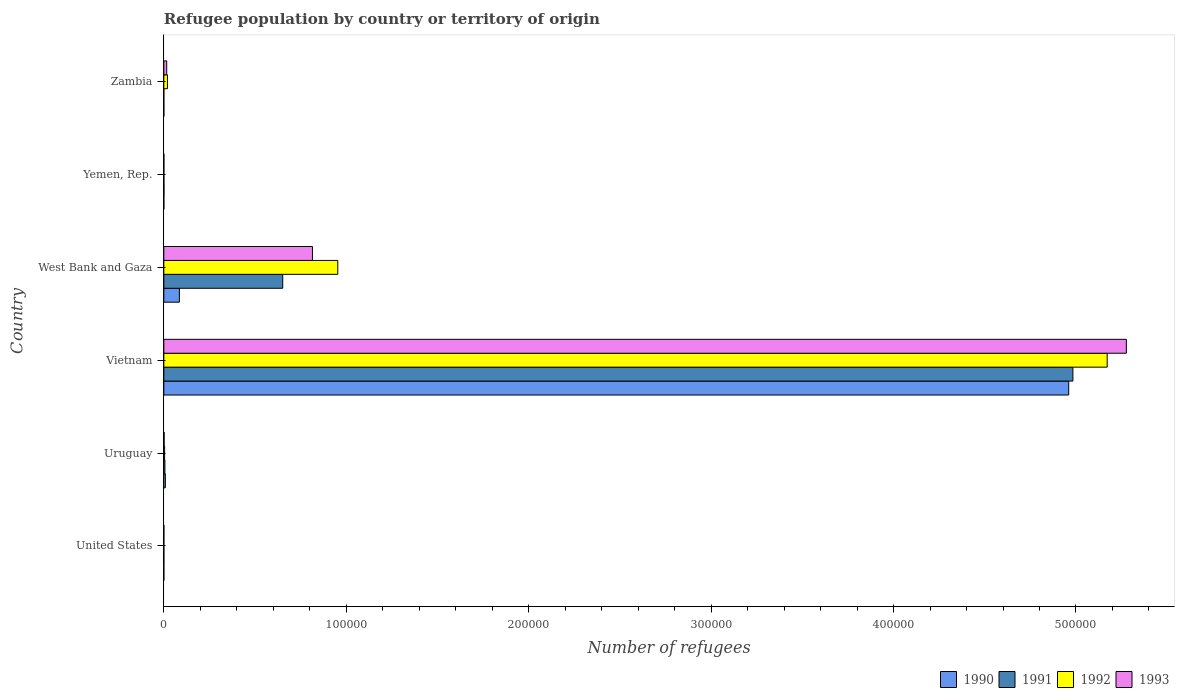What is the label of the 4th group of bars from the top?
Provide a short and direct response. Vietnam. In how many cases, is the number of bars for a given country not equal to the number of legend labels?
Your response must be concise. 0. What is the number of refugees in 1990 in West Bank and Gaza?
Your answer should be very brief. 8521. Across all countries, what is the maximum number of refugees in 1993?
Provide a succinct answer. 5.28e+05. In which country was the number of refugees in 1990 maximum?
Ensure brevity in your answer.  Vietnam. What is the total number of refugees in 1992 in the graph?
Your answer should be compact. 6.15e+05. What is the difference between the number of refugees in 1993 in Yemen, Rep. and that in Zambia?
Make the answer very short. -1535. What is the difference between the number of refugees in 1992 in Vietnam and the number of refugees in 1990 in Uruguay?
Make the answer very short. 5.16e+05. What is the average number of refugees in 1991 per country?
Your response must be concise. 9.40e+04. What is the difference between the number of refugees in 1992 and number of refugees in 1993 in Uruguay?
Offer a very short reply. 267. What is the ratio of the number of refugees in 1992 in Uruguay to that in Vietnam?
Give a very brief answer. 0. Is the number of refugees in 1993 in United States less than that in Yemen, Rep.?
Give a very brief answer. Yes. What is the difference between the highest and the second highest number of refugees in 1993?
Provide a succinct answer. 4.46e+05. What is the difference between the highest and the lowest number of refugees in 1993?
Your answer should be very brief. 5.28e+05. What does the 2nd bar from the top in Uruguay represents?
Keep it short and to the point. 1992. What does the 1st bar from the bottom in West Bank and Gaza represents?
Make the answer very short. 1990. Is it the case that in every country, the sum of the number of refugees in 1990 and number of refugees in 1993 is greater than the number of refugees in 1991?
Ensure brevity in your answer.  No. How many bars are there?
Your answer should be compact. 24. Are all the bars in the graph horizontal?
Provide a short and direct response. Yes. Does the graph contain any zero values?
Provide a short and direct response. No. Does the graph contain grids?
Your answer should be compact. No. What is the title of the graph?
Your answer should be compact. Refugee population by country or territory of origin. Does "2015" appear as one of the legend labels in the graph?
Your answer should be very brief. No. What is the label or title of the X-axis?
Provide a short and direct response. Number of refugees. What is the Number of refugees in 1992 in United States?
Your answer should be very brief. 10. What is the Number of refugees of 1993 in United States?
Offer a terse response. 12. What is the Number of refugees in 1990 in Uruguay?
Your answer should be very brief. 842. What is the Number of refugees of 1991 in Uruguay?
Your answer should be compact. 601. What is the Number of refugees in 1992 in Uruguay?
Offer a terse response. 429. What is the Number of refugees of 1993 in Uruguay?
Your answer should be very brief. 162. What is the Number of refugees of 1990 in Vietnam?
Your response must be concise. 4.96e+05. What is the Number of refugees in 1991 in Vietnam?
Keep it short and to the point. 4.98e+05. What is the Number of refugees of 1992 in Vietnam?
Give a very brief answer. 5.17e+05. What is the Number of refugees in 1993 in Vietnam?
Ensure brevity in your answer.  5.28e+05. What is the Number of refugees of 1990 in West Bank and Gaza?
Your response must be concise. 8521. What is the Number of refugees in 1991 in West Bank and Gaza?
Provide a succinct answer. 6.52e+04. What is the Number of refugees in 1992 in West Bank and Gaza?
Your answer should be very brief. 9.53e+04. What is the Number of refugees of 1993 in West Bank and Gaza?
Give a very brief answer. 8.15e+04. What is the Number of refugees of 1993 in Yemen, Rep.?
Ensure brevity in your answer.  39. What is the Number of refugees in 1990 in Zambia?
Ensure brevity in your answer.  1. What is the Number of refugees in 1992 in Zambia?
Make the answer very short. 1990. What is the Number of refugees of 1993 in Zambia?
Offer a terse response. 1574. Across all countries, what is the maximum Number of refugees in 1990?
Your answer should be very brief. 4.96e+05. Across all countries, what is the maximum Number of refugees in 1991?
Ensure brevity in your answer.  4.98e+05. Across all countries, what is the maximum Number of refugees of 1992?
Provide a succinct answer. 5.17e+05. Across all countries, what is the maximum Number of refugees in 1993?
Offer a very short reply. 5.28e+05. Across all countries, what is the minimum Number of refugees of 1991?
Your response must be concise. 1. Across all countries, what is the minimum Number of refugees of 1993?
Ensure brevity in your answer.  12. What is the total Number of refugees of 1990 in the graph?
Offer a very short reply. 5.05e+05. What is the total Number of refugees in 1991 in the graph?
Keep it short and to the point. 5.64e+05. What is the total Number of refugees of 1992 in the graph?
Offer a terse response. 6.15e+05. What is the total Number of refugees in 1993 in the graph?
Make the answer very short. 6.11e+05. What is the difference between the Number of refugees of 1990 in United States and that in Uruguay?
Give a very brief answer. -841. What is the difference between the Number of refugees in 1991 in United States and that in Uruguay?
Offer a terse response. -593. What is the difference between the Number of refugees in 1992 in United States and that in Uruguay?
Your answer should be very brief. -419. What is the difference between the Number of refugees in 1993 in United States and that in Uruguay?
Ensure brevity in your answer.  -150. What is the difference between the Number of refugees in 1990 in United States and that in Vietnam?
Offer a terse response. -4.96e+05. What is the difference between the Number of refugees of 1991 in United States and that in Vietnam?
Your answer should be compact. -4.98e+05. What is the difference between the Number of refugees of 1992 in United States and that in Vietnam?
Give a very brief answer. -5.17e+05. What is the difference between the Number of refugees in 1993 in United States and that in Vietnam?
Your response must be concise. -5.28e+05. What is the difference between the Number of refugees of 1990 in United States and that in West Bank and Gaza?
Provide a succinct answer. -8520. What is the difference between the Number of refugees of 1991 in United States and that in West Bank and Gaza?
Offer a terse response. -6.52e+04. What is the difference between the Number of refugees in 1992 in United States and that in West Bank and Gaza?
Ensure brevity in your answer.  -9.53e+04. What is the difference between the Number of refugees in 1993 in United States and that in West Bank and Gaza?
Your response must be concise. -8.15e+04. What is the difference between the Number of refugees in 1990 in United States and that in Yemen, Rep.?
Provide a short and direct response. -7. What is the difference between the Number of refugees of 1991 in United States and that in Yemen, Rep.?
Provide a succinct answer. -65. What is the difference between the Number of refugees in 1992 in United States and that in Yemen, Rep.?
Provide a short and direct response. -21. What is the difference between the Number of refugees of 1993 in United States and that in Yemen, Rep.?
Your answer should be very brief. -27. What is the difference between the Number of refugees of 1990 in United States and that in Zambia?
Your answer should be compact. 0. What is the difference between the Number of refugees of 1991 in United States and that in Zambia?
Offer a terse response. 7. What is the difference between the Number of refugees of 1992 in United States and that in Zambia?
Provide a succinct answer. -1980. What is the difference between the Number of refugees of 1993 in United States and that in Zambia?
Keep it short and to the point. -1562. What is the difference between the Number of refugees of 1990 in Uruguay and that in Vietnam?
Provide a short and direct response. -4.95e+05. What is the difference between the Number of refugees of 1991 in Uruguay and that in Vietnam?
Keep it short and to the point. -4.98e+05. What is the difference between the Number of refugees of 1992 in Uruguay and that in Vietnam?
Offer a very short reply. -5.17e+05. What is the difference between the Number of refugees in 1993 in Uruguay and that in Vietnam?
Your answer should be very brief. -5.27e+05. What is the difference between the Number of refugees of 1990 in Uruguay and that in West Bank and Gaza?
Keep it short and to the point. -7679. What is the difference between the Number of refugees of 1991 in Uruguay and that in West Bank and Gaza?
Provide a succinct answer. -6.46e+04. What is the difference between the Number of refugees of 1992 in Uruguay and that in West Bank and Gaza?
Make the answer very short. -9.49e+04. What is the difference between the Number of refugees of 1993 in Uruguay and that in West Bank and Gaza?
Ensure brevity in your answer.  -8.13e+04. What is the difference between the Number of refugees of 1990 in Uruguay and that in Yemen, Rep.?
Provide a short and direct response. 834. What is the difference between the Number of refugees in 1991 in Uruguay and that in Yemen, Rep.?
Make the answer very short. 528. What is the difference between the Number of refugees in 1992 in Uruguay and that in Yemen, Rep.?
Ensure brevity in your answer.  398. What is the difference between the Number of refugees of 1993 in Uruguay and that in Yemen, Rep.?
Keep it short and to the point. 123. What is the difference between the Number of refugees in 1990 in Uruguay and that in Zambia?
Your answer should be very brief. 841. What is the difference between the Number of refugees in 1991 in Uruguay and that in Zambia?
Your answer should be compact. 600. What is the difference between the Number of refugees of 1992 in Uruguay and that in Zambia?
Your answer should be compact. -1561. What is the difference between the Number of refugees of 1993 in Uruguay and that in Zambia?
Provide a short and direct response. -1412. What is the difference between the Number of refugees of 1990 in Vietnam and that in West Bank and Gaza?
Ensure brevity in your answer.  4.88e+05. What is the difference between the Number of refugees of 1991 in Vietnam and that in West Bank and Gaza?
Offer a very short reply. 4.33e+05. What is the difference between the Number of refugees in 1992 in Vietnam and that in West Bank and Gaza?
Provide a succinct answer. 4.22e+05. What is the difference between the Number of refugees in 1993 in Vietnam and that in West Bank and Gaza?
Give a very brief answer. 4.46e+05. What is the difference between the Number of refugees of 1990 in Vietnam and that in Yemen, Rep.?
Your answer should be compact. 4.96e+05. What is the difference between the Number of refugees of 1991 in Vietnam and that in Yemen, Rep.?
Provide a succinct answer. 4.98e+05. What is the difference between the Number of refugees in 1992 in Vietnam and that in Yemen, Rep.?
Make the answer very short. 5.17e+05. What is the difference between the Number of refugees in 1993 in Vietnam and that in Yemen, Rep.?
Keep it short and to the point. 5.28e+05. What is the difference between the Number of refugees in 1990 in Vietnam and that in Zambia?
Give a very brief answer. 4.96e+05. What is the difference between the Number of refugees in 1991 in Vietnam and that in Zambia?
Offer a terse response. 4.98e+05. What is the difference between the Number of refugees of 1992 in Vietnam and that in Zambia?
Ensure brevity in your answer.  5.15e+05. What is the difference between the Number of refugees in 1993 in Vietnam and that in Zambia?
Your response must be concise. 5.26e+05. What is the difference between the Number of refugees of 1990 in West Bank and Gaza and that in Yemen, Rep.?
Ensure brevity in your answer.  8513. What is the difference between the Number of refugees of 1991 in West Bank and Gaza and that in Yemen, Rep.?
Offer a terse response. 6.51e+04. What is the difference between the Number of refugees in 1992 in West Bank and Gaza and that in Yemen, Rep.?
Offer a terse response. 9.53e+04. What is the difference between the Number of refugees in 1993 in West Bank and Gaza and that in Yemen, Rep.?
Offer a very short reply. 8.14e+04. What is the difference between the Number of refugees in 1990 in West Bank and Gaza and that in Zambia?
Keep it short and to the point. 8520. What is the difference between the Number of refugees of 1991 in West Bank and Gaza and that in Zambia?
Your response must be concise. 6.52e+04. What is the difference between the Number of refugees in 1992 in West Bank and Gaza and that in Zambia?
Keep it short and to the point. 9.34e+04. What is the difference between the Number of refugees in 1993 in West Bank and Gaza and that in Zambia?
Your response must be concise. 7.99e+04. What is the difference between the Number of refugees in 1990 in Yemen, Rep. and that in Zambia?
Your answer should be compact. 7. What is the difference between the Number of refugees of 1991 in Yemen, Rep. and that in Zambia?
Provide a short and direct response. 72. What is the difference between the Number of refugees in 1992 in Yemen, Rep. and that in Zambia?
Offer a terse response. -1959. What is the difference between the Number of refugees in 1993 in Yemen, Rep. and that in Zambia?
Provide a succinct answer. -1535. What is the difference between the Number of refugees of 1990 in United States and the Number of refugees of 1991 in Uruguay?
Keep it short and to the point. -600. What is the difference between the Number of refugees of 1990 in United States and the Number of refugees of 1992 in Uruguay?
Make the answer very short. -428. What is the difference between the Number of refugees in 1990 in United States and the Number of refugees in 1993 in Uruguay?
Offer a very short reply. -161. What is the difference between the Number of refugees of 1991 in United States and the Number of refugees of 1992 in Uruguay?
Provide a succinct answer. -421. What is the difference between the Number of refugees of 1991 in United States and the Number of refugees of 1993 in Uruguay?
Make the answer very short. -154. What is the difference between the Number of refugees of 1992 in United States and the Number of refugees of 1993 in Uruguay?
Offer a very short reply. -152. What is the difference between the Number of refugees of 1990 in United States and the Number of refugees of 1991 in Vietnam?
Make the answer very short. -4.98e+05. What is the difference between the Number of refugees of 1990 in United States and the Number of refugees of 1992 in Vietnam?
Keep it short and to the point. -5.17e+05. What is the difference between the Number of refugees in 1990 in United States and the Number of refugees in 1993 in Vietnam?
Provide a succinct answer. -5.28e+05. What is the difference between the Number of refugees of 1991 in United States and the Number of refugees of 1992 in Vietnam?
Offer a very short reply. -5.17e+05. What is the difference between the Number of refugees of 1991 in United States and the Number of refugees of 1993 in Vietnam?
Your answer should be very brief. -5.28e+05. What is the difference between the Number of refugees in 1992 in United States and the Number of refugees in 1993 in Vietnam?
Ensure brevity in your answer.  -5.28e+05. What is the difference between the Number of refugees of 1990 in United States and the Number of refugees of 1991 in West Bank and Gaza?
Provide a succinct answer. -6.52e+04. What is the difference between the Number of refugees of 1990 in United States and the Number of refugees of 1992 in West Bank and Gaza?
Give a very brief answer. -9.53e+04. What is the difference between the Number of refugees of 1990 in United States and the Number of refugees of 1993 in West Bank and Gaza?
Offer a very short reply. -8.15e+04. What is the difference between the Number of refugees of 1991 in United States and the Number of refugees of 1992 in West Bank and Gaza?
Keep it short and to the point. -9.53e+04. What is the difference between the Number of refugees in 1991 in United States and the Number of refugees in 1993 in West Bank and Gaza?
Provide a succinct answer. -8.15e+04. What is the difference between the Number of refugees of 1992 in United States and the Number of refugees of 1993 in West Bank and Gaza?
Ensure brevity in your answer.  -8.15e+04. What is the difference between the Number of refugees of 1990 in United States and the Number of refugees of 1991 in Yemen, Rep.?
Provide a short and direct response. -72. What is the difference between the Number of refugees of 1990 in United States and the Number of refugees of 1992 in Yemen, Rep.?
Provide a succinct answer. -30. What is the difference between the Number of refugees of 1990 in United States and the Number of refugees of 1993 in Yemen, Rep.?
Your answer should be compact. -38. What is the difference between the Number of refugees in 1991 in United States and the Number of refugees in 1992 in Yemen, Rep.?
Ensure brevity in your answer.  -23. What is the difference between the Number of refugees in 1991 in United States and the Number of refugees in 1993 in Yemen, Rep.?
Your response must be concise. -31. What is the difference between the Number of refugees in 1992 in United States and the Number of refugees in 1993 in Yemen, Rep.?
Your answer should be compact. -29. What is the difference between the Number of refugees in 1990 in United States and the Number of refugees in 1991 in Zambia?
Give a very brief answer. 0. What is the difference between the Number of refugees in 1990 in United States and the Number of refugees in 1992 in Zambia?
Offer a very short reply. -1989. What is the difference between the Number of refugees of 1990 in United States and the Number of refugees of 1993 in Zambia?
Provide a succinct answer. -1573. What is the difference between the Number of refugees in 1991 in United States and the Number of refugees in 1992 in Zambia?
Your response must be concise. -1982. What is the difference between the Number of refugees of 1991 in United States and the Number of refugees of 1993 in Zambia?
Your answer should be very brief. -1566. What is the difference between the Number of refugees in 1992 in United States and the Number of refugees in 1993 in Zambia?
Keep it short and to the point. -1564. What is the difference between the Number of refugees in 1990 in Uruguay and the Number of refugees in 1991 in Vietnam?
Ensure brevity in your answer.  -4.97e+05. What is the difference between the Number of refugees in 1990 in Uruguay and the Number of refugees in 1992 in Vietnam?
Provide a short and direct response. -5.16e+05. What is the difference between the Number of refugees of 1990 in Uruguay and the Number of refugees of 1993 in Vietnam?
Offer a terse response. -5.27e+05. What is the difference between the Number of refugees of 1991 in Uruguay and the Number of refugees of 1992 in Vietnam?
Give a very brief answer. -5.17e+05. What is the difference between the Number of refugees in 1991 in Uruguay and the Number of refugees in 1993 in Vietnam?
Your answer should be very brief. -5.27e+05. What is the difference between the Number of refugees of 1992 in Uruguay and the Number of refugees of 1993 in Vietnam?
Offer a very short reply. -5.27e+05. What is the difference between the Number of refugees of 1990 in Uruguay and the Number of refugees of 1991 in West Bank and Gaza?
Your answer should be very brief. -6.43e+04. What is the difference between the Number of refugees in 1990 in Uruguay and the Number of refugees in 1992 in West Bank and Gaza?
Keep it short and to the point. -9.45e+04. What is the difference between the Number of refugees in 1990 in Uruguay and the Number of refugees in 1993 in West Bank and Gaza?
Your answer should be very brief. -8.06e+04. What is the difference between the Number of refugees of 1991 in Uruguay and the Number of refugees of 1992 in West Bank and Gaza?
Keep it short and to the point. -9.47e+04. What is the difference between the Number of refugees in 1991 in Uruguay and the Number of refugees in 1993 in West Bank and Gaza?
Keep it short and to the point. -8.09e+04. What is the difference between the Number of refugees of 1992 in Uruguay and the Number of refugees of 1993 in West Bank and Gaza?
Offer a very short reply. -8.10e+04. What is the difference between the Number of refugees of 1990 in Uruguay and the Number of refugees of 1991 in Yemen, Rep.?
Ensure brevity in your answer.  769. What is the difference between the Number of refugees in 1990 in Uruguay and the Number of refugees in 1992 in Yemen, Rep.?
Offer a very short reply. 811. What is the difference between the Number of refugees of 1990 in Uruguay and the Number of refugees of 1993 in Yemen, Rep.?
Make the answer very short. 803. What is the difference between the Number of refugees in 1991 in Uruguay and the Number of refugees in 1992 in Yemen, Rep.?
Your response must be concise. 570. What is the difference between the Number of refugees of 1991 in Uruguay and the Number of refugees of 1993 in Yemen, Rep.?
Offer a terse response. 562. What is the difference between the Number of refugees of 1992 in Uruguay and the Number of refugees of 1993 in Yemen, Rep.?
Make the answer very short. 390. What is the difference between the Number of refugees of 1990 in Uruguay and the Number of refugees of 1991 in Zambia?
Provide a short and direct response. 841. What is the difference between the Number of refugees in 1990 in Uruguay and the Number of refugees in 1992 in Zambia?
Give a very brief answer. -1148. What is the difference between the Number of refugees of 1990 in Uruguay and the Number of refugees of 1993 in Zambia?
Provide a short and direct response. -732. What is the difference between the Number of refugees in 1991 in Uruguay and the Number of refugees in 1992 in Zambia?
Offer a very short reply. -1389. What is the difference between the Number of refugees of 1991 in Uruguay and the Number of refugees of 1993 in Zambia?
Offer a very short reply. -973. What is the difference between the Number of refugees in 1992 in Uruguay and the Number of refugees in 1993 in Zambia?
Your answer should be compact. -1145. What is the difference between the Number of refugees of 1990 in Vietnam and the Number of refugees of 1991 in West Bank and Gaza?
Your answer should be compact. 4.31e+05. What is the difference between the Number of refugees of 1990 in Vietnam and the Number of refugees of 1992 in West Bank and Gaza?
Keep it short and to the point. 4.01e+05. What is the difference between the Number of refugees in 1990 in Vietnam and the Number of refugees in 1993 in West Bank and Gaza?
Your answer should be compact. 4.15e+05. What is the difference between the Number of refugees in 1991 in Vietnam and the Number of refugees in 1992 in West Bank and Gaza?
Your response must be concise. 4.03e+05. What is the difference between the Number of refugees of 1991 in Vietnam and the Number of refugees of 1993 in West Bank and Gaza?
Give a very brief answer. 4.17e+05. What is the difference between the Number of refugees in 1992 in Vietnam and the Number of refugees in 1993 in West Bank and Gaza?
Keep it short and to the point. 4.36e+05. What is the difference between the Number of refugees of 1990 in Vietnam and the Number of refugees of 1991 in Yemen, Rep.?
Your answer should be very brief. 4.96e+05. What is the difference between the Number of refugees in 1990 in Vietnam and the Number of refugees in 1992 in Yemen, Rep.?
Offer a terse response. 4.96e+05. What is the difference between the Number of refugees of 1990 in Vietnam and the Number of refugees of 1993 in Yemen, Rep.?
Keep it short and to the point. 4.96e+05. What is the difference between the Number of refugees in 1991 in Vietnam and the Number of refugees in 1992 in Yemen, Rep.?
Give a very brief answer. 4.98e+05. What is the difference between the Number of refugees of 1991 in Vietnam and the Number of refugees of 1993 in Yemen, Rep.?
Make the answer very short. 4.98e+05. What is the difference between the Number of refugees in 1992 in Vietnam and the Number of refugees in 1993 in Yemen, Rep.?
Keep it short and to the point. 5.17e+05. What is the difference between the Number of refugees of 1990 in Vietnam and the Number of refugees of 1991 in Zambia?
Keep it short and to the point. 4.96e+05. What is the difference between the Number of refugees in 1990 in Vietnam and the Number of refugees in 1992 in Zambia?
Provide a succinct answer. 4.94e+05. What is the difference between the Number of refugees in 1990 in Vietnam and the Number of refugees in 1993 in Zambia?
Make the answer very short. 4.94e+05. What is the difference between the Number of refugees of 1991 in Vietnam and the Number of refugees of 1992 in Zambia?
Make the answer very short. 4.96e+05. What is the difference between the Number of refugees in 1991 in Vietnam and the Number of refugees in 1993 in Zambia?
Your answer should be very brief. 4.97e+05. What is the difference between the Number of refugees of 1992 in Vietnam and the Number of refugees of 1993 in Zambia?
Your answer should be compact. 5.16e+05. What is the difference between the Number of refugees of 1990 in West Bank and Gaza and the Number of refugees of 1991 in Yemen, Rep.?
Give a very brief answer. 8448. What is the difference between the Number of refugees in 1990 in West Bank and Gaza and the Number of refugees in 1992 in Yemen, Rep.?
Provide a short and direct response. 8490. What is the difference between the Number of refugees in 1990 in West Bank and Gaza and the Number of refugees in 1993 in Yemen, Rep.?
Offer a terse response. 8482. What is the difference between the Number of refugees in 1991 in West Bank and Gaza and the Number of refugees in 1992 in Yemen, Rep.?
Your answer should be very brief. 6.51e+04. What is the difference between the Number of refugees in 1991 in West Bank and Gaza and the Number of refugees in 1993 in Yemen, Rep.?
Keep it short and to the point. 6.51e+04. What is the difference between the Number of refugees of 1992 in West Bank and Gaza and the Number of refugees of 1993 in Yemen, Rep.?
Offer a very short reply. 9.53e+04. What is the difference between the Number of refugees of 1990 in West Bank and Gaza and the Number of refugees of 1991 in Zambia?
Offer a very short reply. 8520. What is the difference between the Number of refugees in 1990 in West Bank and Gaza and the Number of refugees in 1992 in Zambia?
Ensure brevity in your answer.  6531. What is the difference between the Number of refugees of 1990 in West Bank and Gaza and the Number of refugees of 1993 in Zambia?
Provide a succinct answer. 6947. What is the difference between the Number of refugees of 1991 in West Bank and Gaza and the Number of refugees of 1992 in Zambia?
Provide a short and direct response. 6.32e+04. What is the difference between the Number of refugees in 1991 in West Bank and Gaza and the Number of refugees in 1993 in Zambia?
Provide a succinct answer. 6.36e+04. What is the difference between the Number of refugees of 1992 in West Bank and Gaza and the Number of refugees of 1993 in Zambia?
Make the answer very short. 9.38e+04. What is the difference between the Number of refugees of 1990 in Yemen, Rep. and the Number of refugees of 1991 in Zambia?
Your answer should be compact. 7. What is the difference between the Number of refugees of 1990 in Yemen, Rep. and the Number of refugees of 1992 in Zambia?
Your answer should be very brief. -1982. What is the difference between the Number of refugees in 1990 in Yemen, Rep. and the Number of refugees in 1993 in Zambia?
Your answer should be compact. -1566. What is the difference between the Number of refugees in 1991 in Yemen, Rep. and the Number of refugees in 1992 in Zambia?
Give a very brief answer. -1917. What is the difference between the Number of refugees in 1991 in Yemen, Rep. and the Number of refugees in 1993 in Zambia?
Provide a succinct answer. -1501. What is the difference between the Number of refugees of 1992 in Yemen, Rep. and the Number of refugees of 1993 in Zambia?
Make the answer very short. -1543. What is the average Number of refugees in 1990 per country?
Provide a short and direct response. 8.42e+04. What is the average Number of refugees in 1991 per country?
Offer a very short reply. 9.40e+04. What is the average Number of refugees in 1992 per country?
Ensure brevity in your answer.  1.02e+05. What is the average Number of refugees of 1993 per country?
Provide a succinct answer. 1.02e+05. What is the difference between the Number of refugees in 1991 and Number of refugees in 1993 in United States?
Provide a short and direct response. -4. What is the difference between the Number of refugees of 1992 and Number of refugees of 1993 in United States?
Provide a short and direct response. -2. What is the difference between the Number of refugees in 1990 and Number of refugees in 1991 in Uruguay?
Your answer should be very brief. 241. What is the difference between the Number of refugees in 1990 and Number of refugees in 1992 in Uruguay?
Make the answer very short. 413. What is the difference between the Number of refugees in 1990 and Number of refugees in 1993 in Uruguay?
Provide a succinct answer. 680. What is the difference between the Number of refugees in 1991 and Number of refugees in 1992 in Uruguay?
Your answer should be very brief. 172. What is the difference between the Number of refugees in 1991 and Number of refugees in 1993 in Uruguay?
Your response must be concise. 439. What is the difference between the Number of refugees of 1992 and Number of refugees of 1993 in Uruguay?
Ensure brevity in your answer.  267. What is the difference between the Number of refugees of 1990 and Number of refugees of 1991 in Vietnam?
Ensure brevity in your answer.  -2294. What is the difference between the Number of refugees of 1990 and Number of refugees of 1992 in Vietnam?
Your answer should be compact. -2.11e+04. What is the difference between the Number of refugees in 1990 and Number of refugees in 1993 in Vietnam?
Offer a very short reply. -3.16e+04. What is the difference between the Number of refugees in 1991 and Number of refugees in 1992 in Vietnam?
Your answer should be compact. -1.88e+04. What is the difference between the Number of refugees of 1991 and Number of refugees of 1993 in Vietnam?
Your response must be concise. -2.93e+04. What is the difference between the Number of refugees in 1992 and Number of refugees in 1993 in Vietnam?
Your response must be concise. -1.05e+04. What is the difference between the Number of refugees of 1990 and Number of refugees of 1991 in West Bank and Gaza?
Provide a short and direct response. -5.67e+04. What is the difference between the Number of refugees in 1990 and Number of refugees in 1992 in West Bank and Gaza?
Ensure brevity in your answer.  -8.68e+04. What is the difference between the Number of refugees of 1990 and Number of refugees of 1993 in West Bank and Gaza?
Your answer should be compact. -7.30e+04. What is the difference between the Number of refugees of 1991 and Number of refugees of 1992 in West Bank and Gaza?
Provide a short and direct response. -3.02e+04. What is the difference between the Number of refugees in 1991 and Number of refugees in 1993 in West Bank and Gaza?
Keep it short and to the point. -1.63e+04. What is the difference between the Number of refugees in 1992 and Number of refugees in 1993 in West Bank and Gaza?
Your answer should be compact. 1.39e+04. What is the difference between the Number of refugees in 1990 and Number of refugees in 1991 in Yemen, Rep.?
Your answer should be very brief. -65. What is the difference between the Number of refugees in 1990 and Number of refugees in 1992 in Yemen, Rep.?
Offer a terse response. -23. What is the difference between the Number of refugees of 1990 and Number of refugees of 1993 in Yemen, Rep.?
Provide a short and direct response. -31. What is the difference between the Number of refugees of 1992 and Number of refugees of 1993 in Yemen, Rep.?
Give a very brief answer. -8. What is the difference between the Number of refugees in 1990 and Number of refugees in 1992 in Zambia?
Offer a terse response. -1989. What is the difference between the Number of refugees in 1990 and Number of refugees in 1993 in Zambia?
Provide a succinct answer. -1573. What is the difference between the Number of refugees of 1991 and Number of refugees of 1992 in Zambia?
Make the answer very short. -1989. What is the difference between the Number of refugees in 1991 and Number of refugees in 1993 in Zambia?
Make the answer very short. -1573. What is the difference between the Number of refugees in 1992 and Number of refugees in 1993 in Zambia?
Your answer should be compact. 416. What is the ratio of the Number of refugees in 1990 in United States to that in Uruguay?
Ensure brevity in your answer.  0. What is the ratio of the Number of refugees in 1991 in United States to that in Uruguay?
Offer a very short reply. 0.01. What is the ratio of the Number of refugees of 1992 in United States to that in Uruguay?
Make the answer very short. 0.02. What is the ratio of the Number of refugees in 1993 in United States to that in Uruguay?
Give a very brief answer. 0.07. What is the ratio of the Number of refugees of 1990 in United States to that in Vietnam?
Your response must be concise. 0. What is the ratio of the Number of refugees of 1991 in United States to that in Vietnam?
Your response must be concise. 0. What is the ratio of the Number of refugees of 1992 in United States to that in Vietnam?
Ensure brevity in your answer.  0. What is the ratio of the Number of refugees in 1993 in United States to that in Vietnam?
Make the answer very short. 0. What is the ratio of the Number of refugees in 1991 in United States to that in West Bank and Gaza?
Provide a succinct answer. 0. What is the ratio of the Number of refugees of 1992 in United States to that in West Bank and Gaza?
Make the answer very short. 0. What is the ratio of the Number of refugees in 1993 in United States to that in West Bank and Gaza?
Offer a terse response. 0. What is the ratio of the Number of refugees of 1991 in United States to that in Yemen, Rep.?
Ensure brevity in your answer.  0.11. What is the ratio of the Number of refugees in 1992 in United States to that in Yemen, Rep.?
Your answer should be compact. 0.32. What is the ratio of the Number of refugees of 1993 in United States to that in Yemen, Rep.?
Your answer should be very brief. 0.31. What is the ratio of the Number of refugees in 1990 in United States to that in Zambia?
Your answer should be very brief. 1. What is the ratio of the Number of refugees in 1991 in United States to that in Zambia?
Your answer should be compact. 8. What is the ratio of the Number of refugees in 1992 in United States to that in Zambia?
Keep it short and to the point. 0.01. What is the ratio of the Number of refugees in 1993 in United States to that in Zambia?
Offer a very short reply. 0.01. What is the ratio of the Number of refugees in 1990 in Uruguay to that in Vietnam?
Ensure brevity in your answer.  0. What is the ratio of the Number of refugees of 1991 in Uruguay to that in Vietnam?
Offer a terse response. 0. What is the ratio of the Number of refugees of 1992 in Uruguay to that in Vietnam?
Your answer should be compact. 0. What is the ratio of the Number of refugees of 1993 in Uruguay to that in Vietnam?
Give a very brief answer. 0. What is the ratio of the Number of refugees in 1990 in Uruguay to that in West Bank and Gaza?
Your answer should be compact. 0.1. What is the ratio of the Number of refugees in 1991 in Uruguay to that in West Bank and Gaza?
Your answer should be very brief. 0.01. What is the ratio of the Number of refugees in 1992 in Uruguay to that in West Bank and Gaza?
Ensure brevity in your answer.  0. What is the ratio of the Number of refugees in 1993 in Uruguay to that in West Bank and Gaza?
Provide a short and direct response. 0. What is the ratio of the Number of refugees in 1990 in Uruguay to that in Yemen, Rep.?
Offer a very short reply. 105.25. What is the ratio of the Number of refugees in 1991 in Uruguay to that in Yemen, Rep.?
Provide a succinct answer. 8.23. What is the ratio of the Number of refugees in 1992 in Uruguay to that in Yemen, Rep.?
Your answer should be very brief. 13.84. What is the ratio of the Number of refugees in 1993 in Uruguay to that in Yemen, Rep.?
Offer a terse response. 4.15. What is the ratio of the Number of refugees of 1990 in Uruguay to that in Zambia?
Make the answer very short. 842. What is the ratio of the Number of refugees of 1991 in Uruguay to that in Zambia?
Offer a terse response. 601. What is the ratio of the Number of refugees in 1992 in Uruguay to that in Zambia?
Your answer should be very brief. 0.22. What is the ratio of the Number of refugees of 1993 in Uruguay to that in Zambia?
Make the answer very short. 0.1. What is the ratio of the Number of refugees of 1990 in Vietnam to that in West Bank and Gaza?
Offer a terse response. 58.21. What is the ratio of the Number of refugees of 1991 in Vietnam to that in West Bank and Gaza?
Keep it short and to the point. 7.65. What is the ratio of the Number of refugees in 1992 in Vietnam to that in West Bank and Gaza?
Offer a very short reply. 5.42. What is the ratio of the Number of refugees of 1993 in Vietnam to that in West Bank and Gaza?
Offer a terse response. 6.48. What is the ratio of the Number of refugees of 1990 in Vietnam to that in Yemen, Rep.?
Provide a short and direct response. 6.20e+04. What is the ratio of the Number of refugees of 1991 in Vietnam to that in Yemen, Rep.?
Your answer should be very brief. 6826.34. What is the ratio of the Number of refugees of 1992 in Vietnam to that in Yemen, Rep.?
Provide a succinct answer. 1.67e+04. What is the ratio of the Number of refugees in 1993 in Vietnam to that in Yemen, Rep.?
Provide a succinct answer. 1.35e+04. What is the ratio of the Number of refugees in 1990 in Vietnam to that in Zambia?
Your answer should be very brief. 4.96e+05. What is the ratio of the Number of refugees of 1991 in Vietnam to that in Zambia?
Your answer should be very brief. 4.98e+05. What is the ratio of the Number of refugees of 1992 in Vietnam to that in Zambia?
Provide a short and direct response. 259.85. What is the ratio of the Number of refugees of 1993 in Vietnam to that in Zambia?
Offer a terse response. 335.21. What is the ratio of the Number of refugees of 1990 in West Bank and Gaza to that in Yemen, Rep.?
Your answer should be compact. 1065.12. What is the ratio of the Number of refugees of 1991 in West Bank and Gaza to that in Yemen, Rep.?
Keep it short and to the point. 892.84. What is the ratio of the Number of refugees in 1992 in West Bank and Gaza to that in Yemen, Rep.?
Offer a terse response. 3075.58. What is the ratio of the Number of refugees of 1993 in West Bank and Gaza to that in Yemen, Rep.?
Your answer should be compact. 2089.08. What is the ratio of the Number of refugees in 1990 in West Bank and Gaza to that in Zambia?
Ensure brevity in your answer.  8521. What is the ratio of the Number of refugees of 1991 in West Bank and Gaza to that in Zambia?
Ensure brevity in your answer.  6.52e+04. What is the ratio of the Number of refugees in 1992 in West Bank and Gaza to that in Zambia?
Your answer should be very brief. 47.91. What is the ratio of the Number of refugees of 1993 in West Bank and Gaza to that in Zambia?
Your answer should be very brief. 51.76. What is the ratio of the Number of refugees in 1991 in Yemen, Rep. to that in Zambia?
Your answer should be very brief. 73. What is the ratio of the Number of refugees in 1992 in Yemen, Rep. to that in Zambia?
Ensure brevity in your answer.  0.02. What is the ratio of the Number of refugees in 1993 in Yemen, Rep. to that in Zambia?
Your answer should be very brief. 0.02. What is the difference between the highest and the second highest Number of refugees of 1990?
Give a very brief answer. 4.88e+05. What is the difference between the highest and the second highest Number of refugees in 1991?
Ensure brevity in your answer.  4.33e+05. What is the difference between the highest and the second highest Number of refugees of 1992?
Keep it short and to the point. 4.22e+05. What is the difference between the highest and the second highest Number of refugees in 1993?
Provide a short and direct response. 4.46e+05. What is the difference between the highest and the lowest Number of refugees of 1990?
Offer a terse response. 4.96e+05. What is the difference between the highest and the lowest Number of refugees in 1991?
Keep it short and to the point. 4.98e+05. What is the difference between the highest and the lowest Number of refugees in 1992?
Ensure brevity in your answer.  5.17e+05. What is the difference between the highest and the lowest Number of refugees in 1993?
Your answer should be compact. 5.28e+05. 